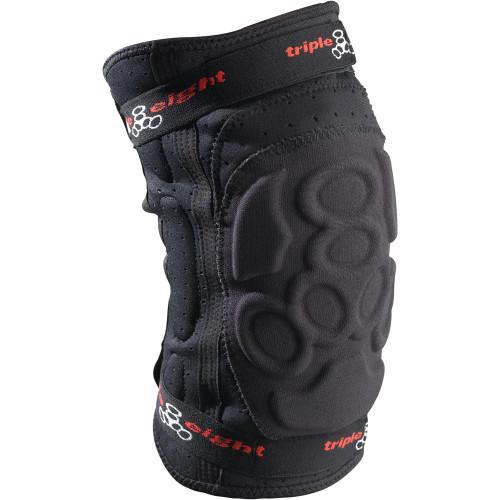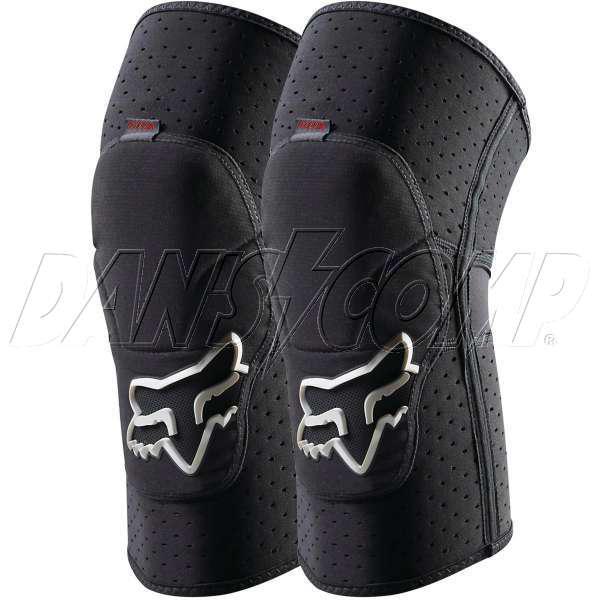The first image is the image on the left, the second image is the image on the right. Evaluate the accuracy of this statement regarding the images: "One pair of guards is incomplete.". Is it true? Answer yes or no. Yes. The first image is the image on the left, the second image is the image on the right. Considering the images on both sides, is "The left image contains one kneepad, while the right image contains a pair." valid? Answer yes or no. Yes. 